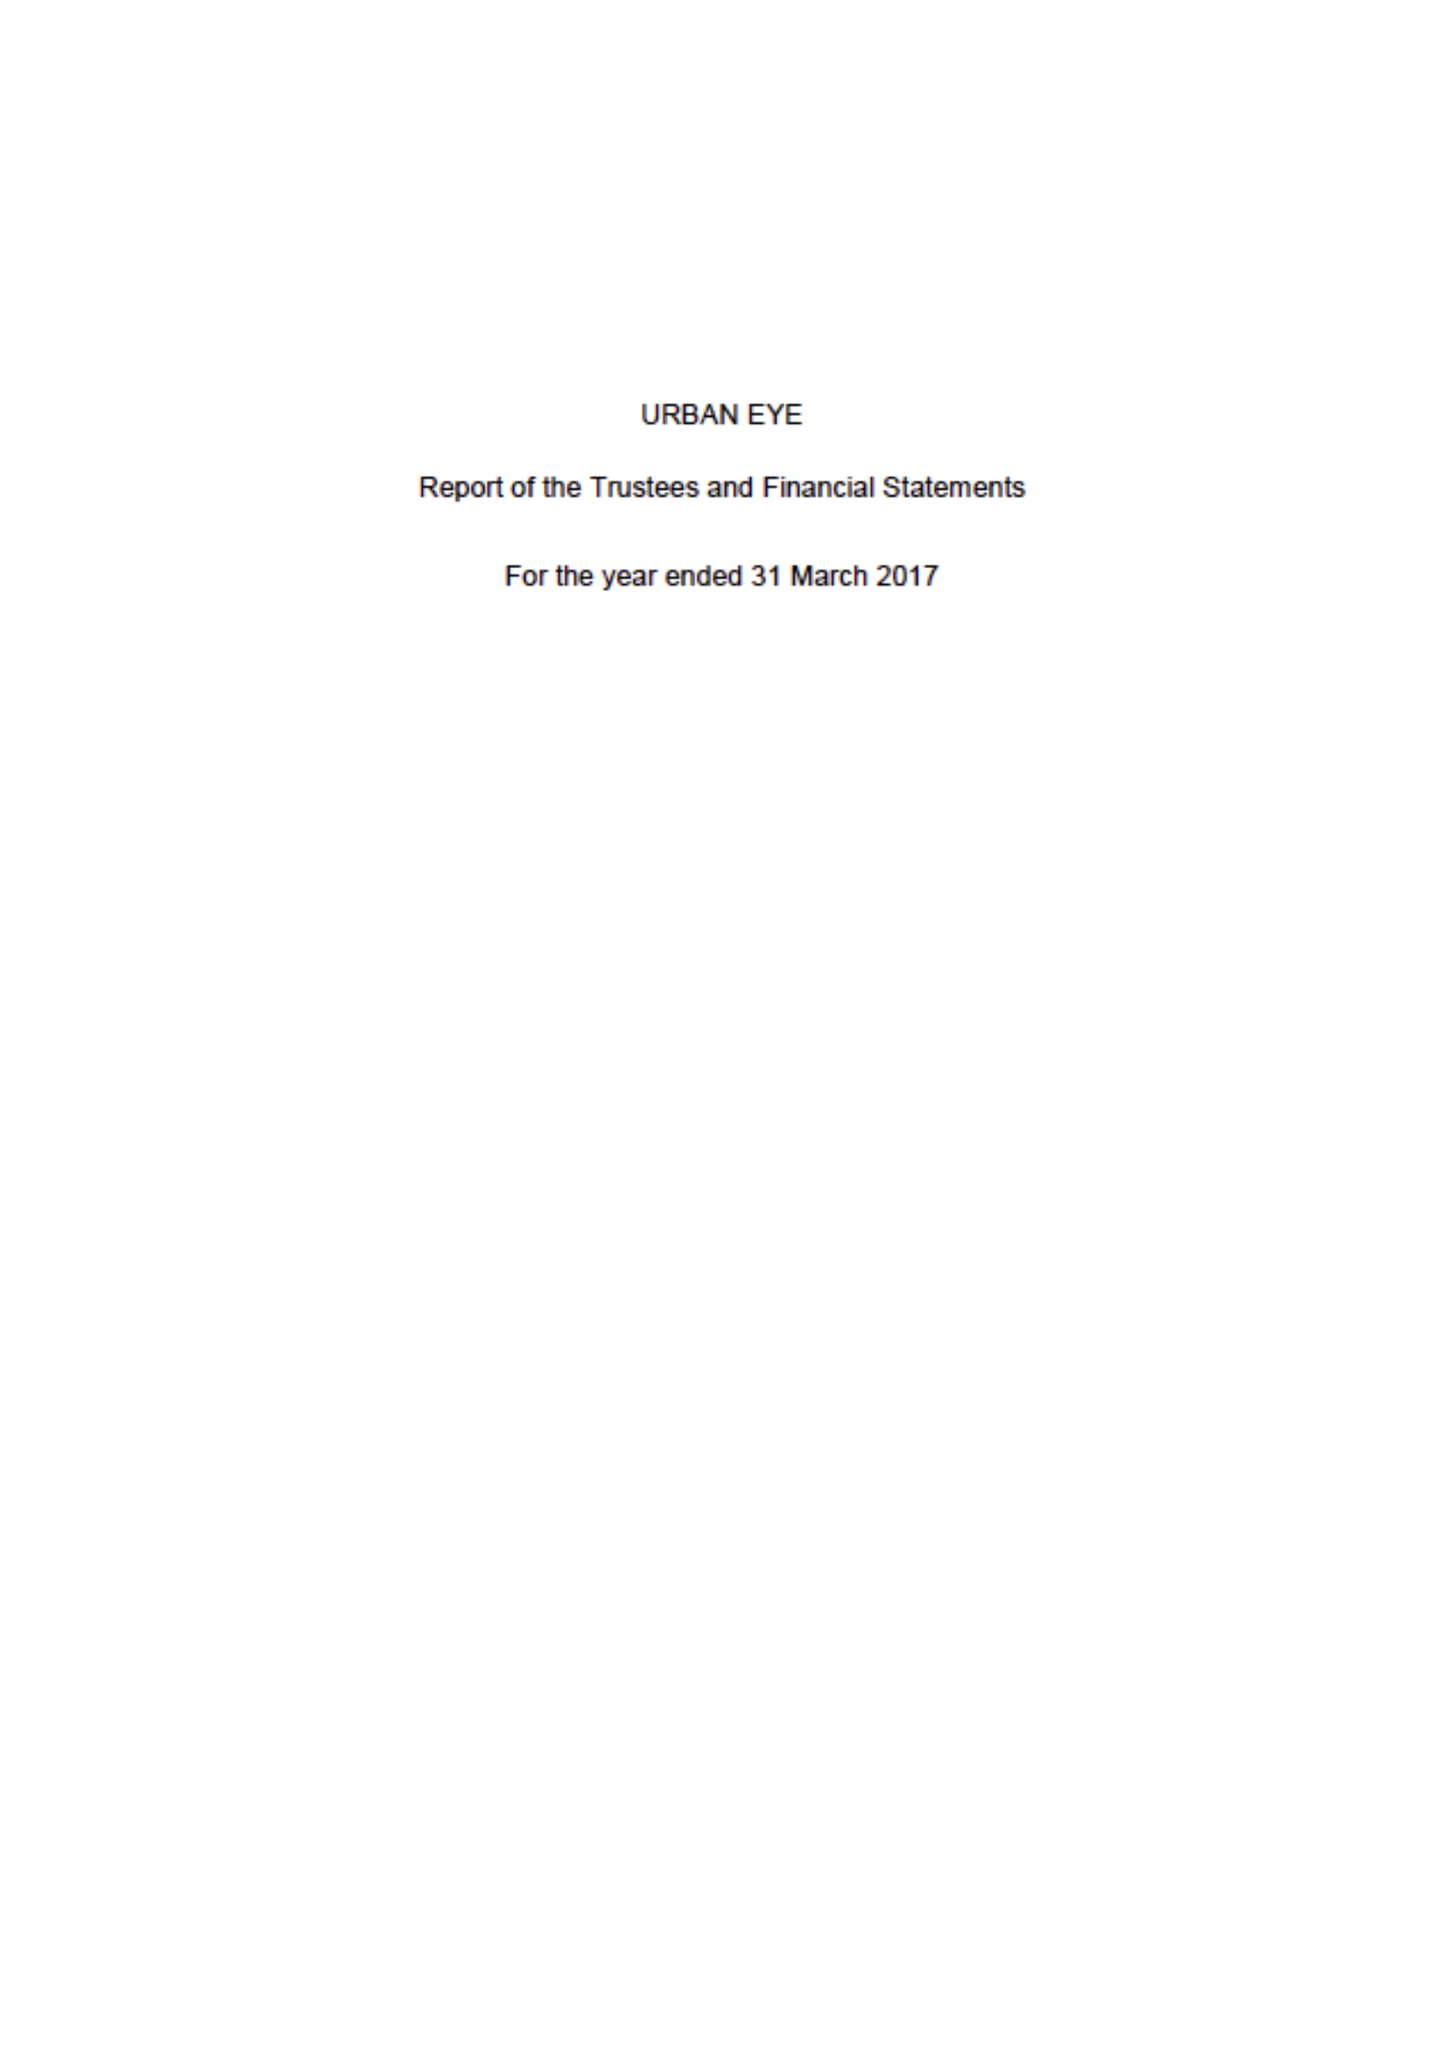What is the value for the income_annually_in_british_pounds?
Answer the question using a single word or phrase. 66354.00 